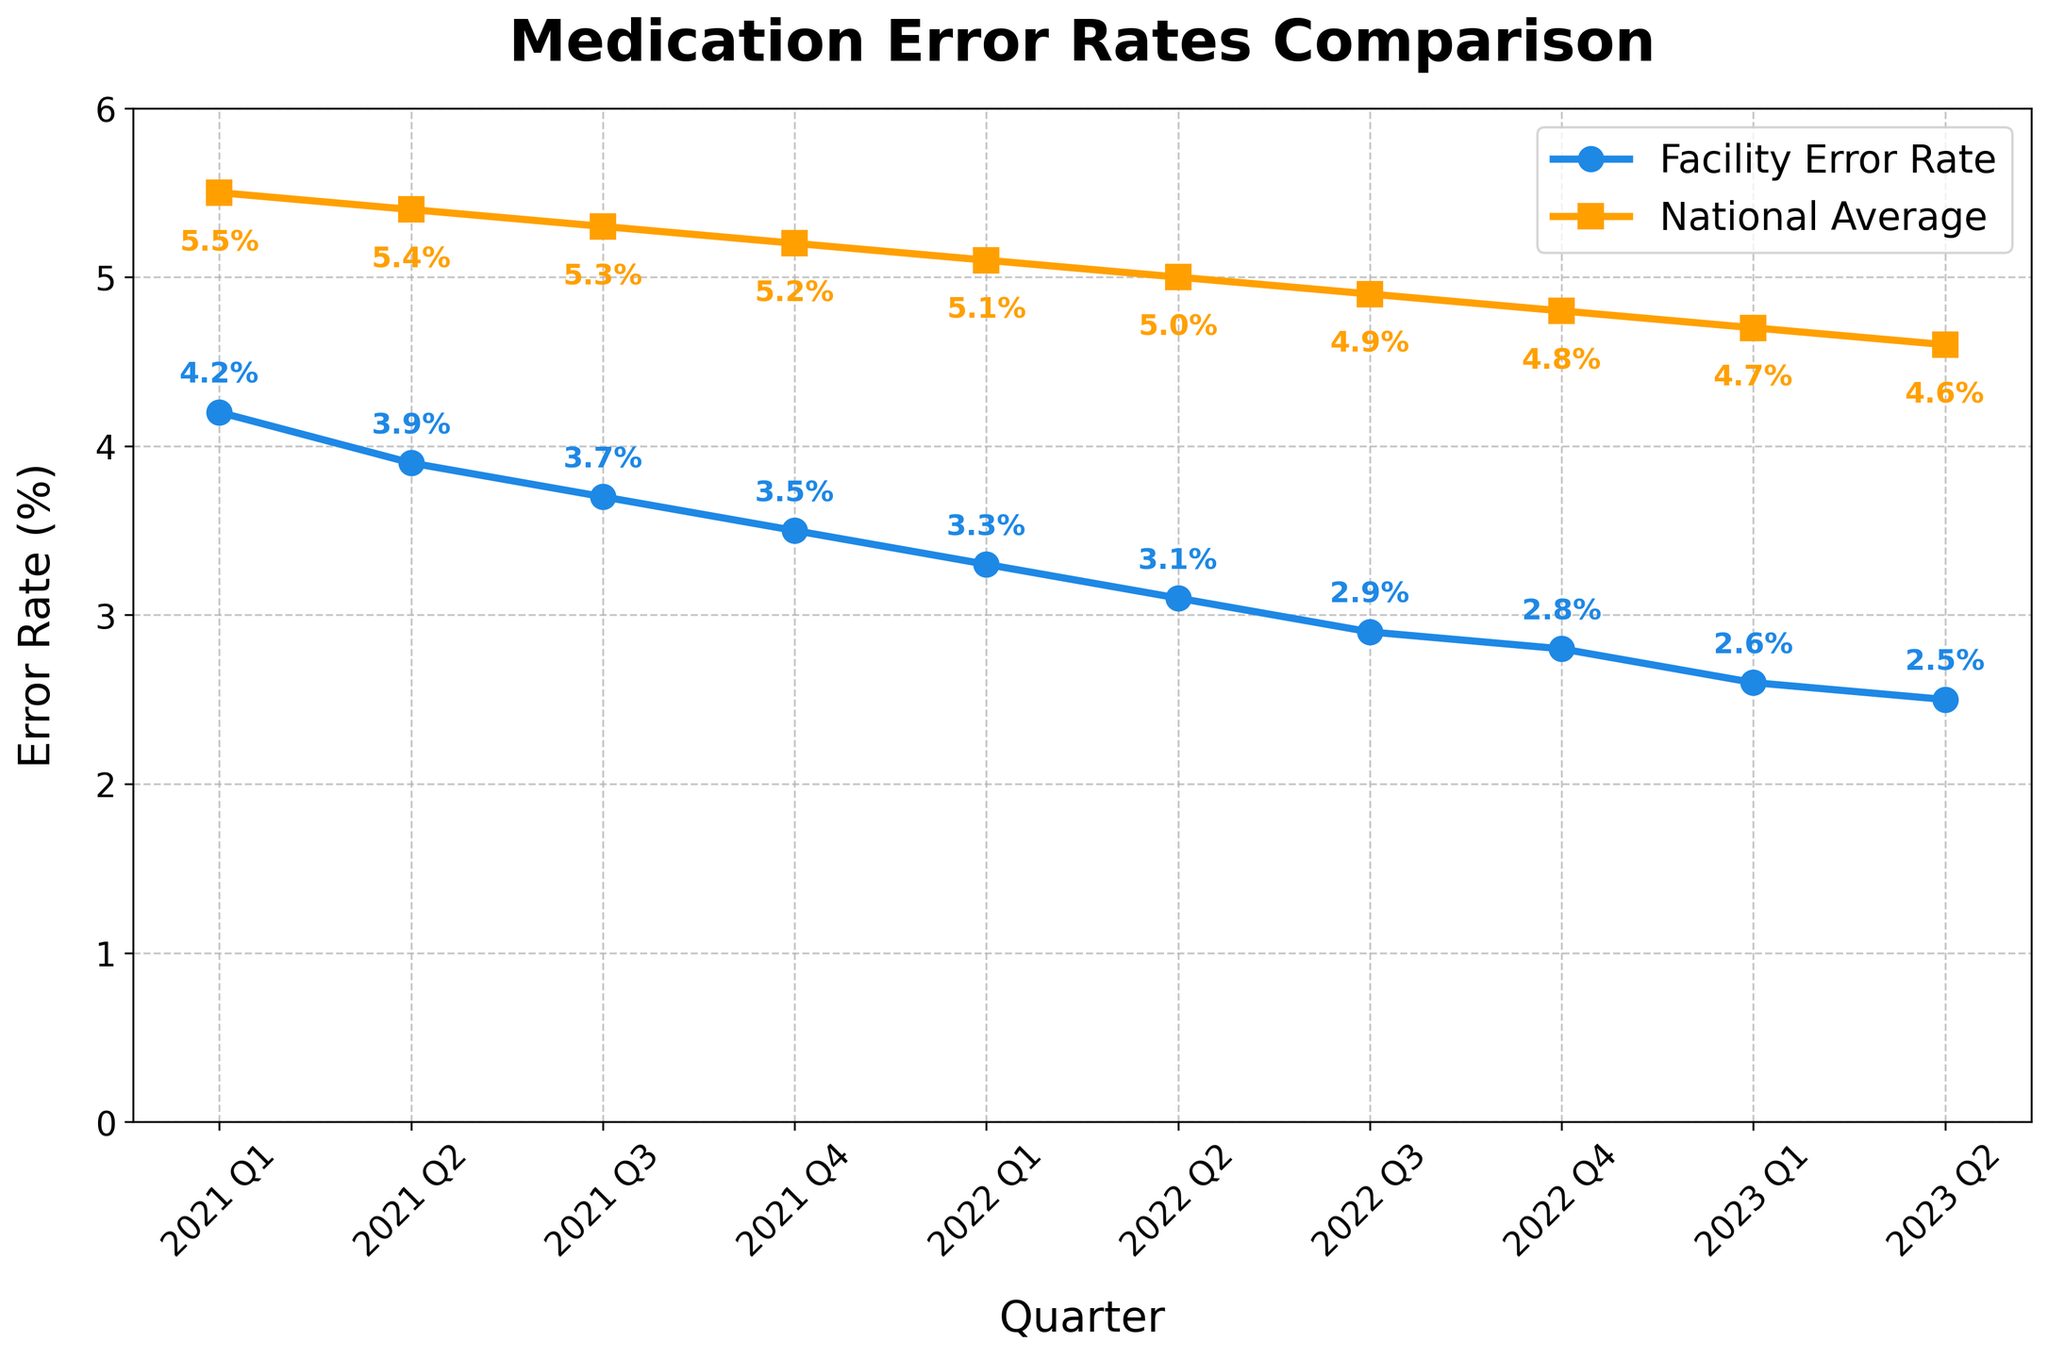What's the overall trend of the facility's medication error rate over the quarters? Visually observe that the error rate of the facility starts high and continuously decreases over each quarter.
Answer: Decreasing How does the facility's error rate in 2021 Q4 compare to the national average in the same quarter? Locate the points for the facility's error rate and the national average in 2021 Q4. The facility's error rate is 3.5%, and the national average is 5.2%.
Answer: Facility error rate is lower What is the difference between the facility's error rate and the national average in 2023 Q2? Subtract the facility's error rate (2.5%) from the national average (4.6%). 4.6% - 2.5% = 2.1%
Answer: 2.1% Between which two consecutive quarters did the facility's error rate decrease the most? Compare the differences between consecutive quarters for the facility's error rate. The decrease is: 
2021 Q1-Q2: 4.2 - 3.9 = 0.3 
2021 Q2-Q3: 3.9 - 3.7 = 0.2 
2021 Q3-Q4: 3.7 - 3.5 = 0.2 
2022 Q1-Q2: 3.3 - 3.1 = 0.2 
2022 Q2-Q3: 3.1 - 2.9 = 0.2 
2022 Q3-Q4: 2.9 - 2.8 = 0.1 
2023 Q1-Q2: 2.6 - 2.5 = 0.1 The largest decrease is 0.3 between 2021 Q1 and Q2.
Answer: 2021 Q1-Q2 What is the average national error rate from 2021 Q1 to 2023 Q2? Sum all the national error rates from each quarter and divide by the number of quarters: (5.5 + 5.4 + 5.3 + 5.2 + 5.1 + 5.0 + 4.9 + 4.8 + 4.7 + 4.6) / 10 = 50.5 / 10 = 5.05%
Answer: 5.05% Is there any quarter in which the facility's error rate is higher than the national average? Compare the facility's error rate with the national average for each quarter. The facility's error rate is always lower in all quarters.
Answer: No By how much did the facility's error rate decrease from the first recorded quarter to the last one? Subtract the facility's error rate in the last quarter (2023 Q2, 2.5%) from the first recorded quarter (2021 Q1, 4.2%). 4.2% - 2.5% = 1.7%
Answer: 1.7% Which quarter had the smallest gap between the facility's error rate and the national average? Calculate the gap for each quarter: 
2021 Q1: 5.5 - 4.2 = 1.3 
2021 Q2: 5.4 - 3.9 = 1.5 
2021 Q3: 5.3 - 3.7 = 1.6 
2021 Q4: 5.2 - 3.5 = 1.7 
2022 Q1: 5.1 - 3.3 = 1.8 
2022 Q2: 5.0 - 3.1 = 1.9 
2022 Q3: 4.9 - 2.9 = 2.0 
2022 Q4: 4.8 - 2.8 = 2.0 
2023 Q1: 4.7 - 2.6 = 2.1 
2023 Q2: 4.6 - 2.5 = 2.1 The smallest gap is 1.3 in 2021 Q1.
Answer: 2021 Q1 